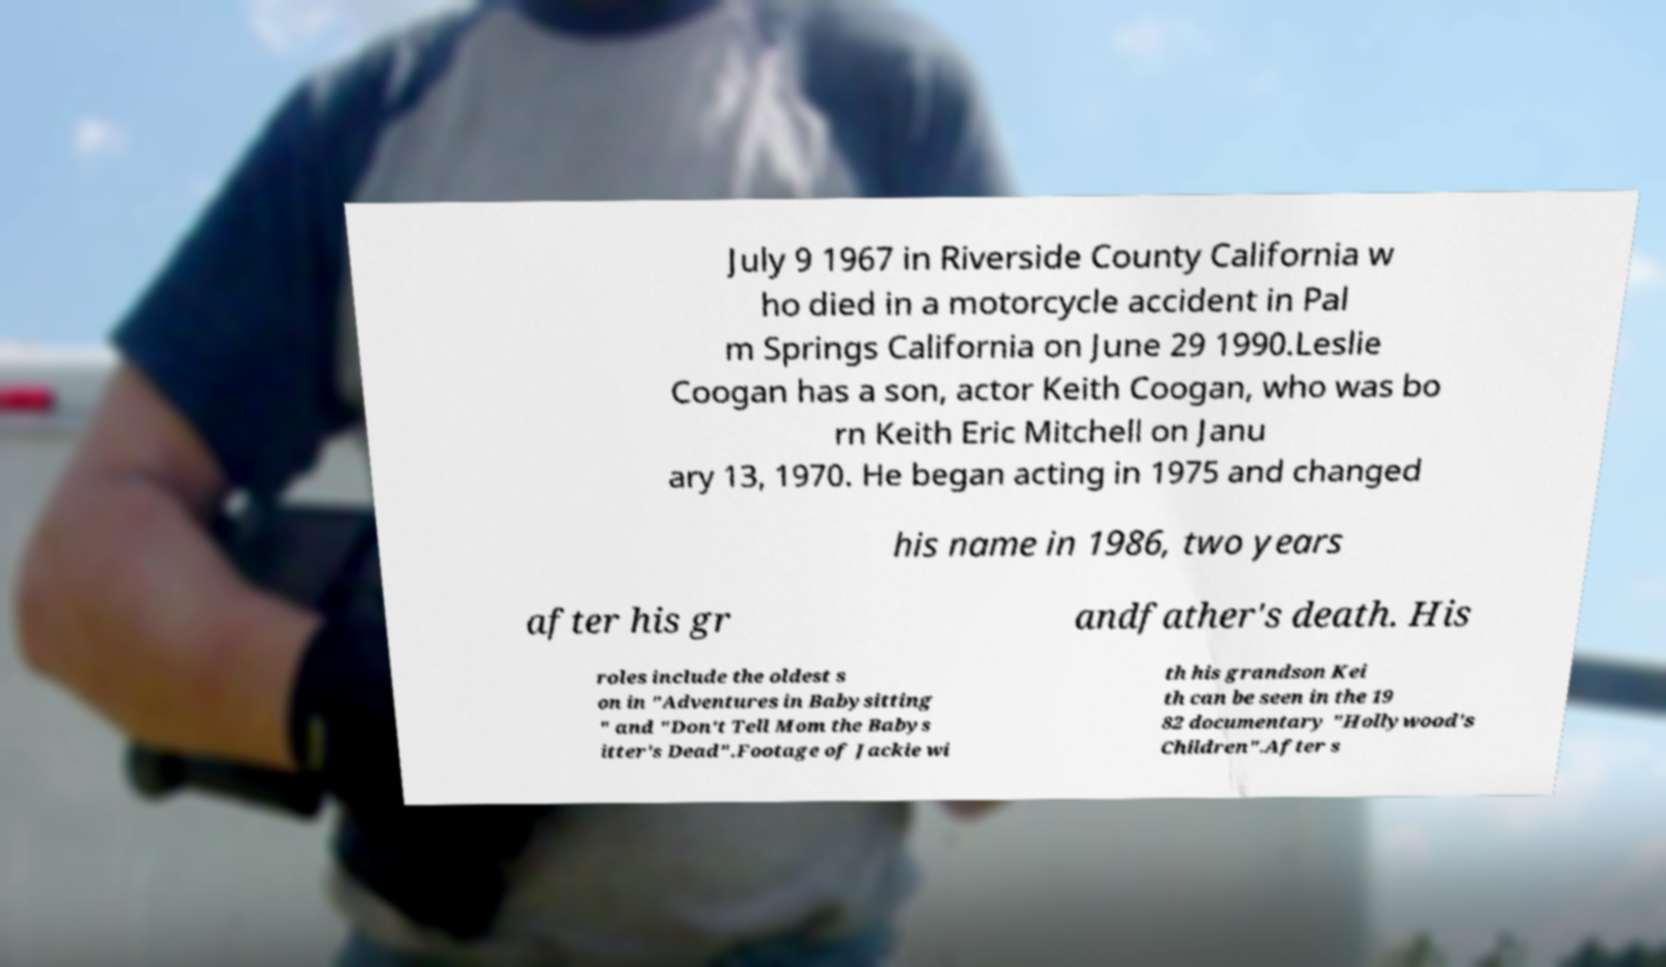Can you read and provide the text displayed in the image?This photo seems to have some interesting text. Can you extract and type it out for me? July 9 1967 in Riverside County California w ho died in a motorcycle accident in Pal m Springs California on June 29 1990.Leslie Coogan has a son, actor Keith Coogan, who was bo rn Keith Eric Mitchell on Janu ary 13, 1970. He began acting in 1975 and changed his name in 1986, two years after his gr andfather's death. His roles include the oldest s on in "Adventures in Babysitting " and "Don't Tell Mom the Babys itter's Dead".Footage of Jackie wi th his grandson Kei th can be seen in the 19 82 documentary "Hollywood's Children".After s 